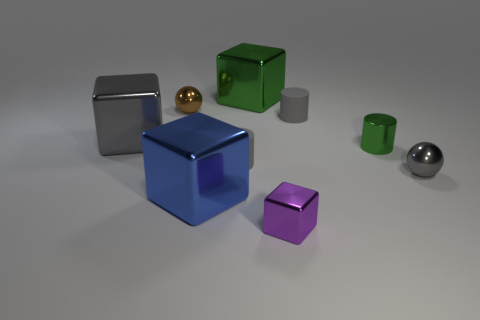Add 1 small cyan matte things. How many objects exist? 10 Subtract all cubes. How many objects are left? 5 Add 6 yellow metallic spheres. How many yellow metallic spheres exist? 6 Subtract 1 gray spheres. How many objects are left? 8 Subtract all red metallic things. Subtract all small green metal cylinders. How many objects are left? 8 Add 8 tiny gray metallic spheres. How many tiny gray metallic spheres are left? 9 